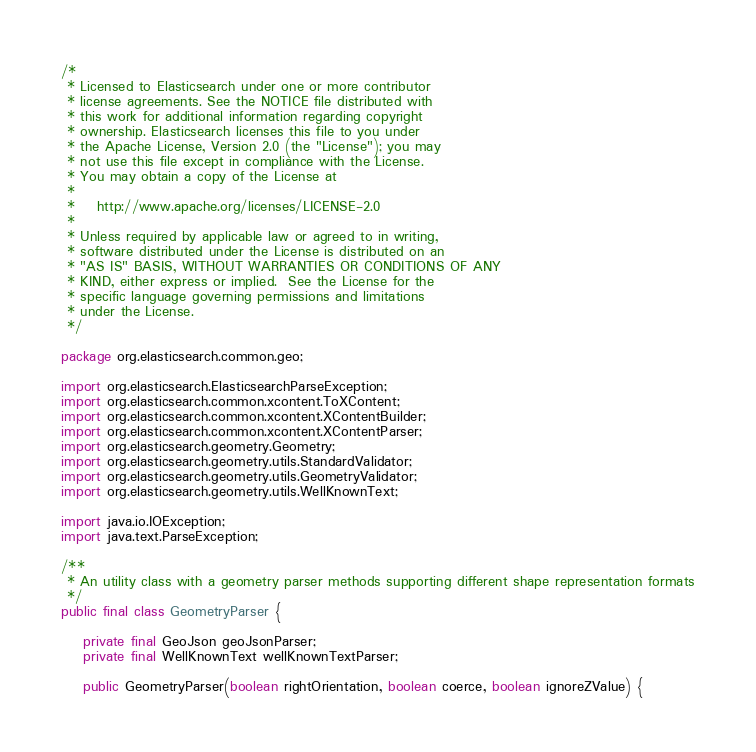Convert code to text. <code><loc_0><loc_0><loc_500><loc_500><_Java_>/*
 * Licensed to Elasticsearch under one or more contributor
 * license agreements. See the NOTICE file distributed with
 * this work for additional information regarding copyright
 * ownership. Elasticsearch licenses this file to you under
 * the Apache License, Version 2.0 (the "License"); you may
 * not use this file except in compliance with the License.
 * You may obtain a copy of the License at
 *
 *    http://www.apache.org/licenses/LICENSE-2.0
 *
 * Unless required by applicable law or agreed to in writing,
 * software distributed under the License is distributed on an
 * "AS IS" BASIS, WITHOUT WARRANTIES OR CONDITIONS OF ANY
 * KIND, either express or implied.  See the License for the
 * specific language governing permissions and limitations
 * under the License.
 */

package org.elasticsearch.common.geo;

import org.elasticsearch.ElasticsearchParseException;
import org.elasticsearch.common.xcontent.ToXContent;
import org.elasticsearch.common.xcontent.XContentBuilder;
import org.elasticsearch.common.xcontent.XContentParser;
import org.elasticsearch.geometry.Geometry;
import org.elasticsearch.geometry.utils.StandardValidator;
import org.elasticsearch.geometry.utils.GeometryValidator;
import org.elasticsearch.geometry.utils.WellKnownText;

import java.io.IOException;
import java.text.ParseException;

/**
 * An utility class with a geometry parser methods supporting different shape representation formats
 */
public final class GeometryParser {

    private final GeoJson geoJsonParser;
    private final WellKnownText wellKnownTextParser;

    public GeometryParser(boolean rightOrientation, boolean coerce, boolean ignoreZValue) {</code> 